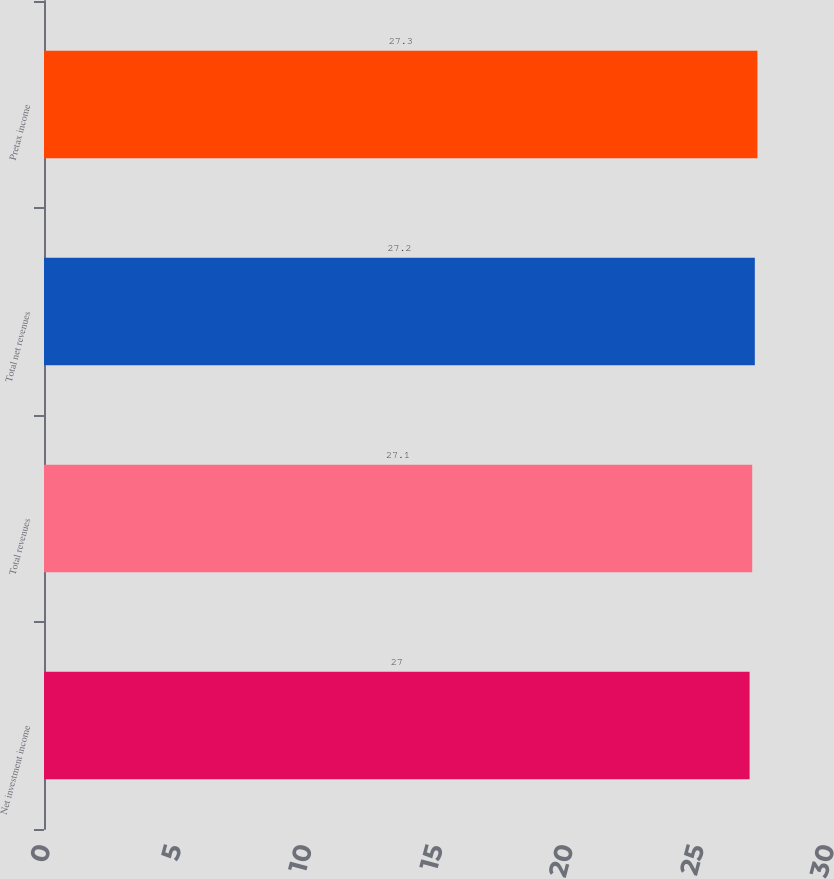Convert chart. <chart><loc_0><loc_0><loc_500><loc_500><bar_chart><fcel>Net investment income<fcel>Total revenues<fcel>Total net revenues<fcel>Pretax income<nl><fcel>27<fcel>27.1<fcel>27.2<fcel>27.3<nl></chart> 